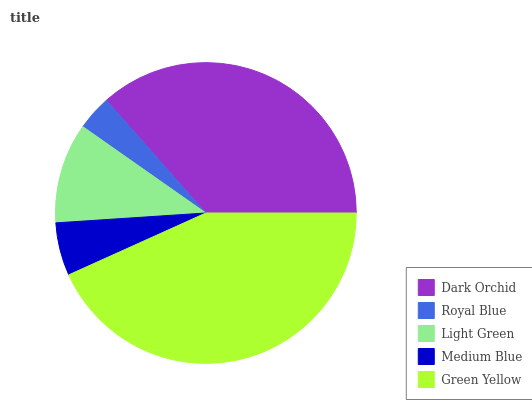Is Royal Blue the minimum?
Answer yes or no. Yes. Is Green Yellow the maximum?
Answer yes or no. Yes. Is Light Green the minimum?
Answer yes or no. No. Is Light Green the maximum?
Answer yes or no. No. Is Light Green greater than Royal Blue?
Answer yes or no. Yes. Is Royal Blue less than Light Green?
Answer yes or no. Yes. Is Royal Blue greater than Light Green?
Answer yes or no. No. Is Light Green less than Royal Blue?
Answer yes or no. No. Is Light Green the high median?
Answer yes or no. Yes. Is Light Green the low median?
Answer yes or no. Yes. Is Green Yellow the high median?
Answer yes or no. No. Is Green Yellow the low median?
Answer yes or no. No. 